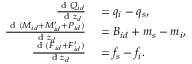Convert formula to latex. <formula><loc_0><loc_0><loc_500><loc_500>\begin{array} { r l } { \frac { d Q _ { i d } } { d z _ { d } } } & = q _ { i } - q _ { s } , } \\ { \frac { d ( M _ { i d } + M _ { i d } ^ { \prime } + P _ { i d } ) } { d z _ { d } } } & = B _ { i d } + m _ { s } - m _ { i } , } \\ { \frac { d ( F _ { i d } + F _ { i d } ^ { \prime } ) } { d z _ { d } } } & = f _ { s } - f _ { i } . } \end{array}</formula> 